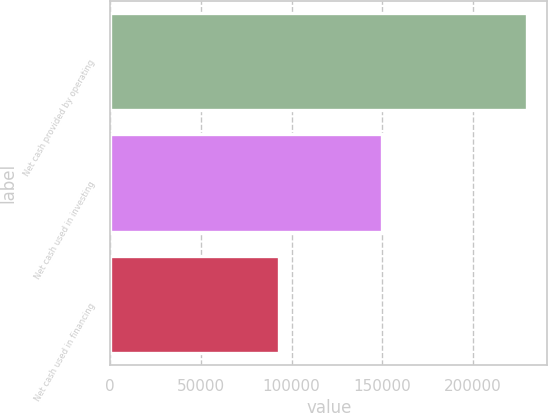Convert chart. <chart><loc_0><loc_0><loc_500><loc_500><bar_chart><fcel>Net cash provided by operating<fcel>Net cash used in investing<fcel>Net cash used in financing<nl><fcel>229613<fcel>149973<fcel>93040<nl></chart> 